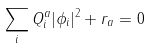<formula> <loc_0><loc_0><loc_500><loc_500>\sum _ { i } Q _ { i } ^ { a } | \phi _ { i } | ^ { 2 } + r _ { a } = 0</formula> 